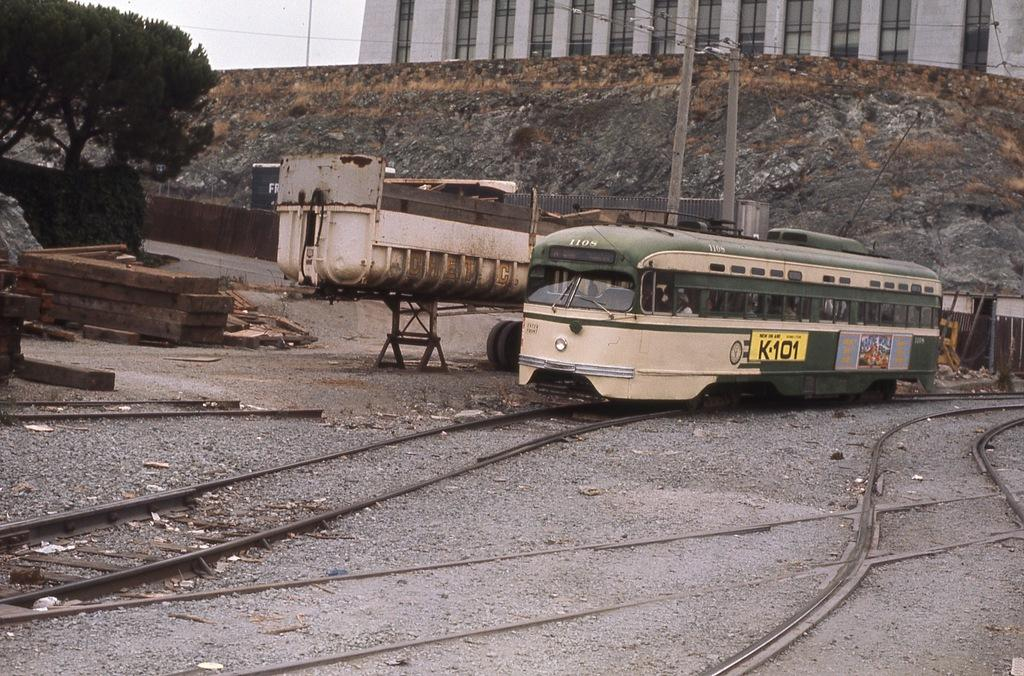<image>
Describe the image concisely. Old bus with a yellow sign which says K101. 